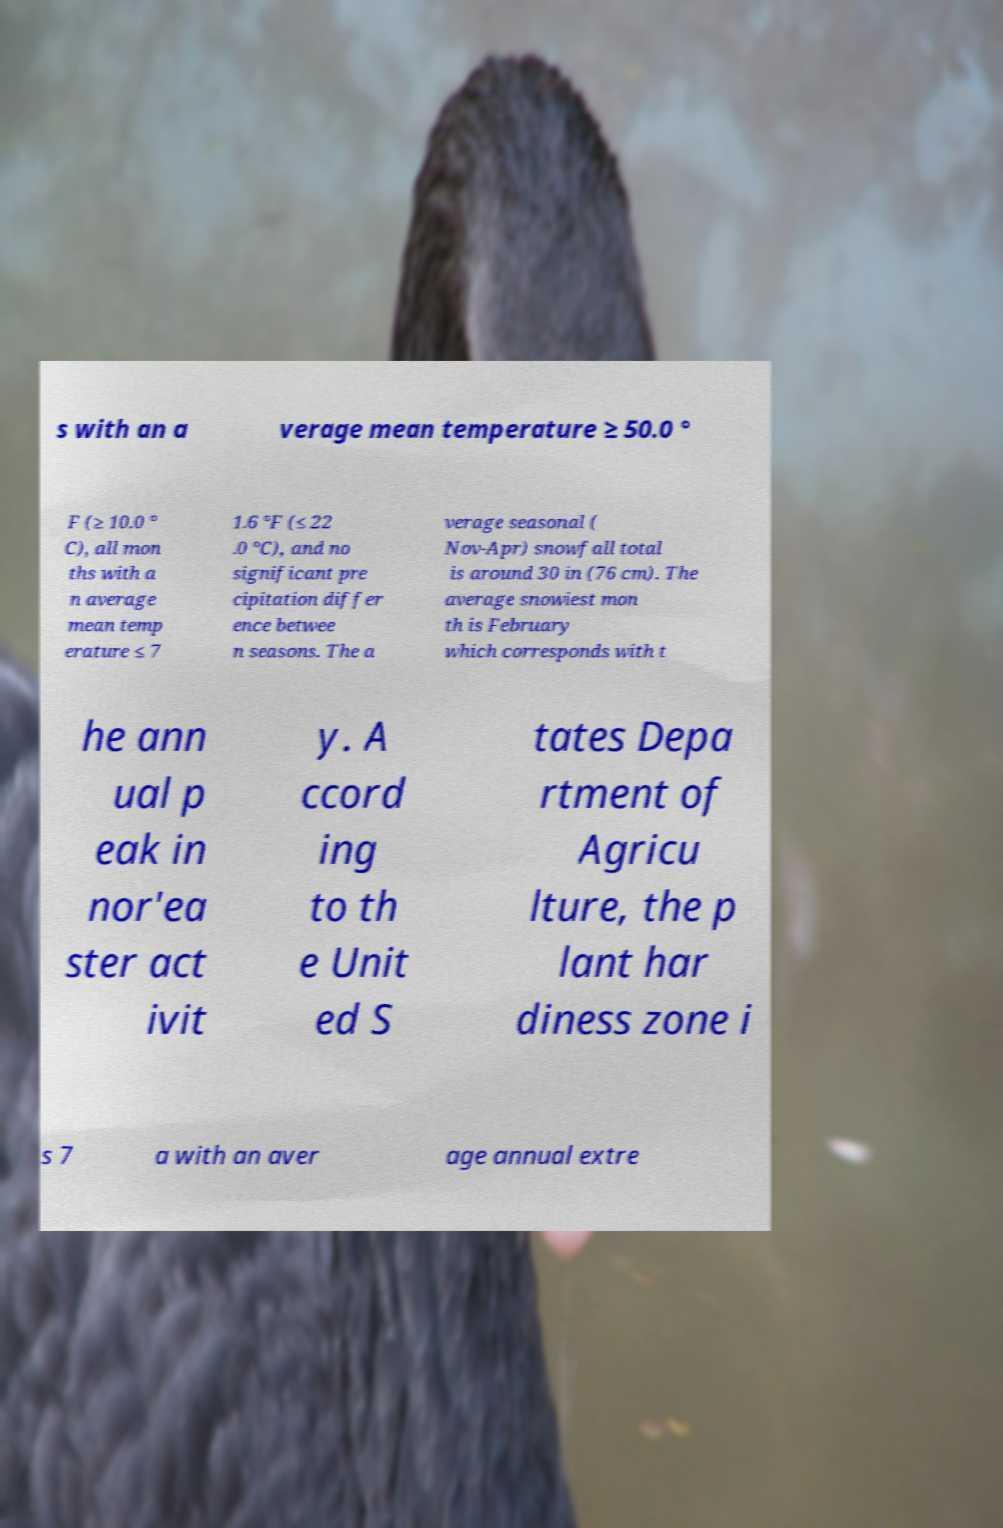What messages or text are displayed in this image? I need them in a readable, typed format. s with an a verage mean temperature ≥ 50.0 ° F (≥ 10.0 ° C), all mon ths with a n average mean temp erature ≤ 7 1.6 °F (≤ 22 .0 °C), and no significant pre cipitation differ ence betwee n seasons. The a verage seasonal ( Nov-Apr) snowfall total is around 30 in (76 cm). The average snowiest mon th is February which corresponds with t he ann ual p eak in nor'ea ster act ivit y. A ccord ing to th e Unit ed S tates Depa rtment of Agricu lture, the p lant har diness zone i s 7 a with an aver age annual extre 